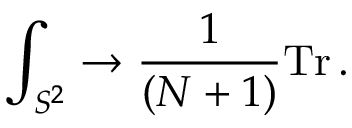Convert formula to latex. <formula><loc_0><loc_0><loc_500><loc_500>\int _ { S ^ { 2 } } \to { \frac { 1 } { ( N + 1 ) } } T r \, .</formula> 